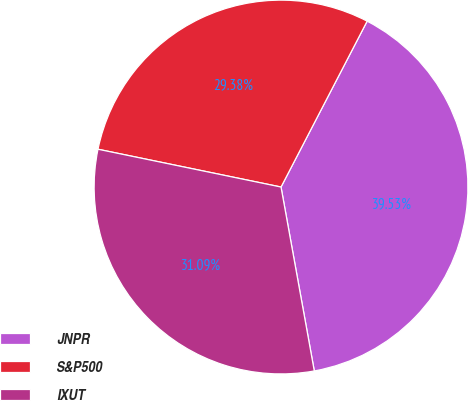<chart> <loc_0><loc_0><loc_500><loc_500><pie_chart><fcel>JNPR<fcel>S&P500<fcel>IXUT<nl><fcel>39.53%<fcel>29.38%<fcel>31.09%<nl></chart> 